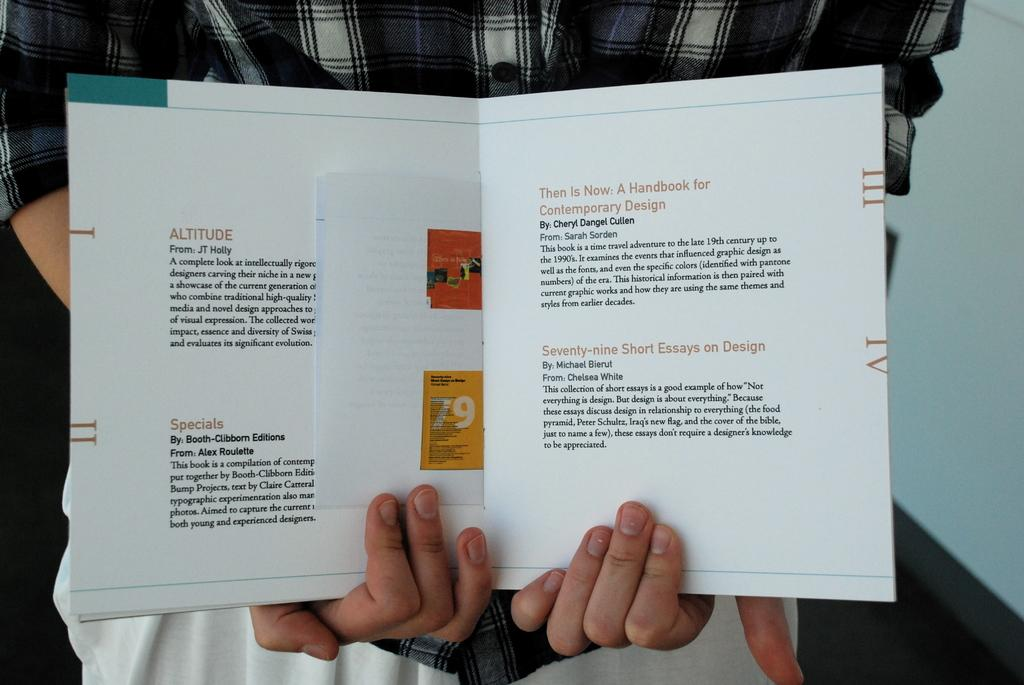<image>
Present a compact description of the photo's key features. A pamphlet that says ALTITUDE From: JT Holly among other entries. 